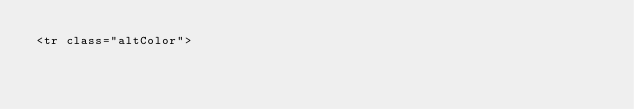<code> <loc_0><loc_0><loc_500><loc_500><_HTML_><tr class="altColor"></code> 